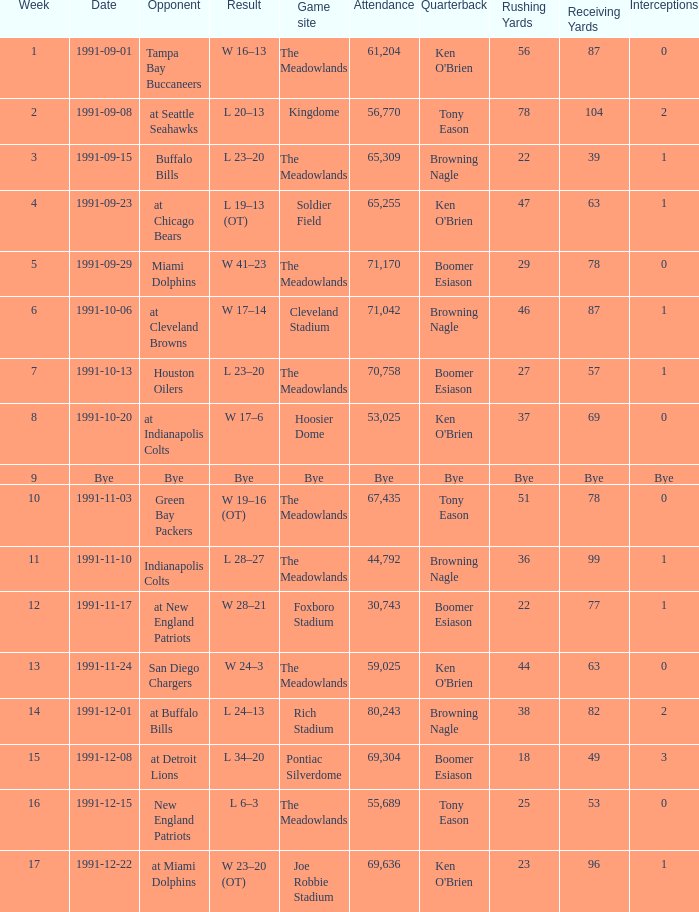What was the spectator turnout at the hoosier dome game? 53025.0. 